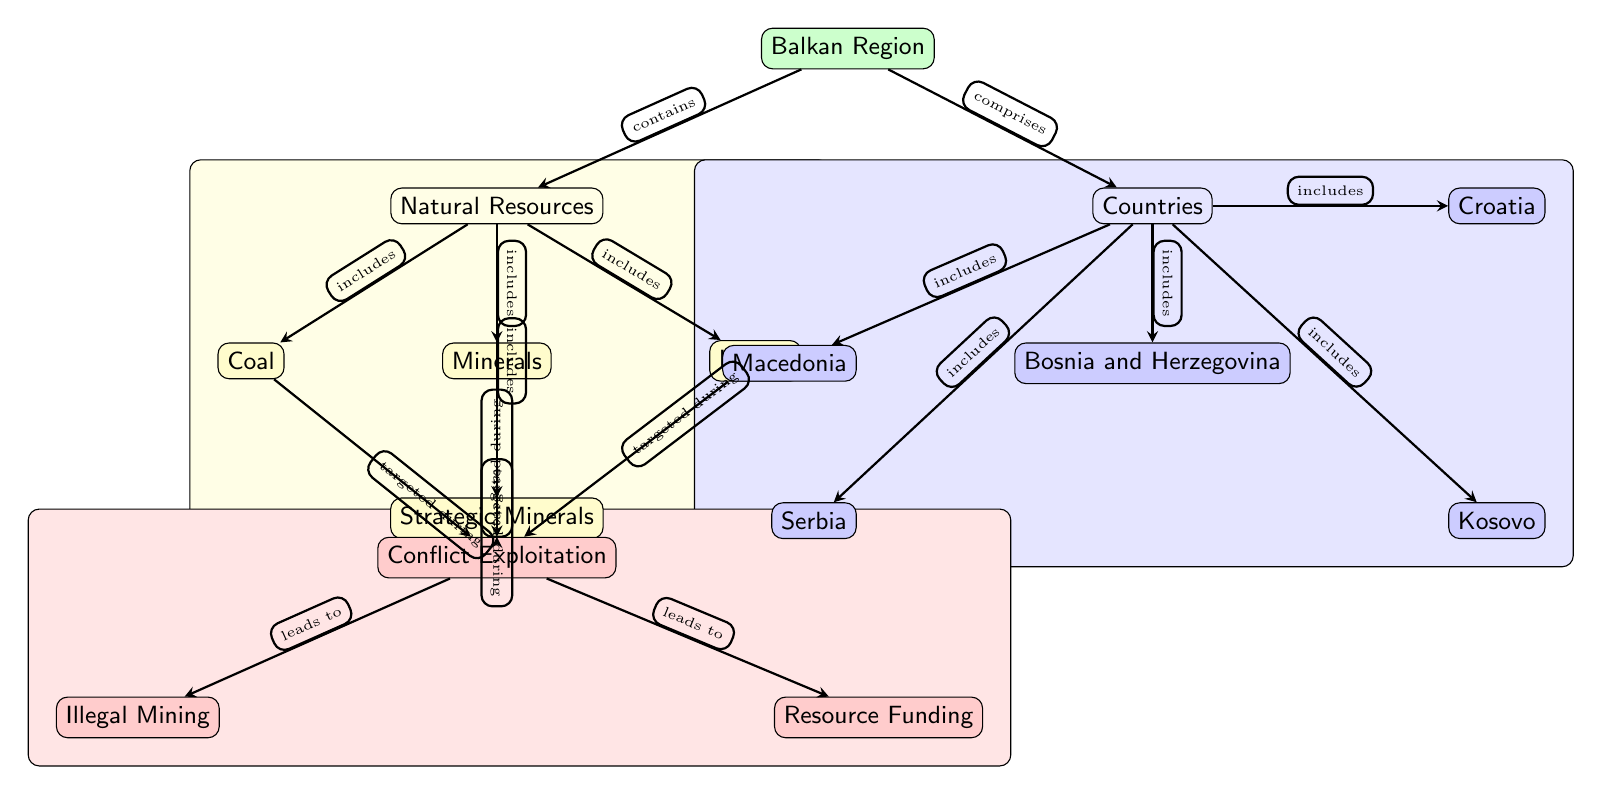What is the main focus of the diagram? The diagram centers on the geographic distribution of natural resources in the Balkan region and their exploitation during conflicts. This can be found in the main node labeled "Balkan Region."
Answer: Balkan Region How many countries are represented in this diagram? There are five countries listed in the diagram, specifically Bosnia and Herzegovina, Croatia, Kosovo, Serbia, and Macedonia. By counting the nodes under the "Countries" label, we find five.
Answer: 5 Which natural resource is categorized as "strategic"? The node labeled "Strategic Minerals" indicates that it is categorized as a strategic natural resource. This can be found by reviewing the resources listed under "Natural Resources."
Answer: Strategic Minerals What leads to illegal mining according to the diagram? The arrow from "Conflict Exploitation" to "Illegal Mining" shows that this activity leads to illegal mining, indicating that conflicts are the factor that triggers this exploitation.
Answer: Conflict Exploitation Which country is directly below Bosnia in the diagram? The node directly below Bosnia and Herzegovina is Serbia, as the connections of the diagram show that Serbia is positioned below Bosnia and Herzegovina.
Answer: Serbia What type of exploitation is indicated under "Conflict Exploitation"? Two types of exploitation are indicated, with "Illegal Mining" and "Resource Funding" being the primary activities that are categorized as this form of exploitation.
Answer: Illegal Mining and Resource Funding How does "Natural Resources" relate to "Countries"? The arrow from "Balkan Region" to "Countries" indicates that the Balkan Region comprises these countries, signifying strong connections between both concepts.
Answer: comprises What activities are targeted during conflict? The diagram shows that "Minerals," "Coal," "Lignite," and "Strategic Minerals" are all mentioned as resources that are targeted during conflicts. This conclusion is drawn from examining the arrows leading from resources to "Conflict Exploitation."
Answer: Minerals, Coal, Lignite, Strategic Minerals What is the main exploitation described in the diagram? The main exploitation type described in the diagram is "Conflict Exploitation," as indicated by the central node linked to multiple types of resource exploitation.
Answer: Conflict Exploitation 